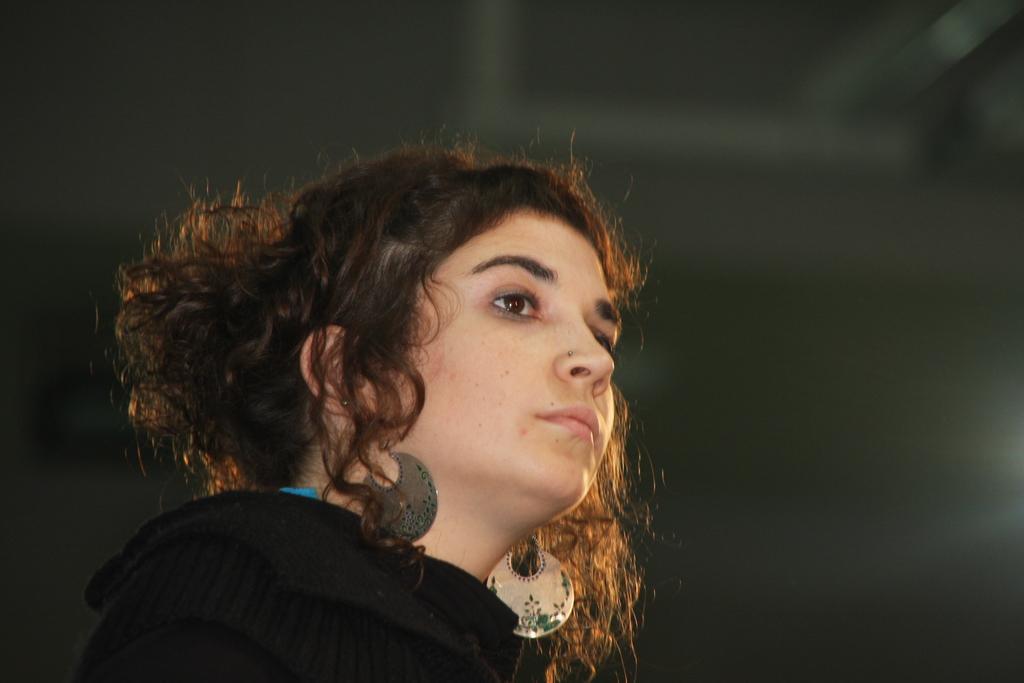How would you summarize this image in a sentence or two? In this image, we can see a person wearing clothes. 